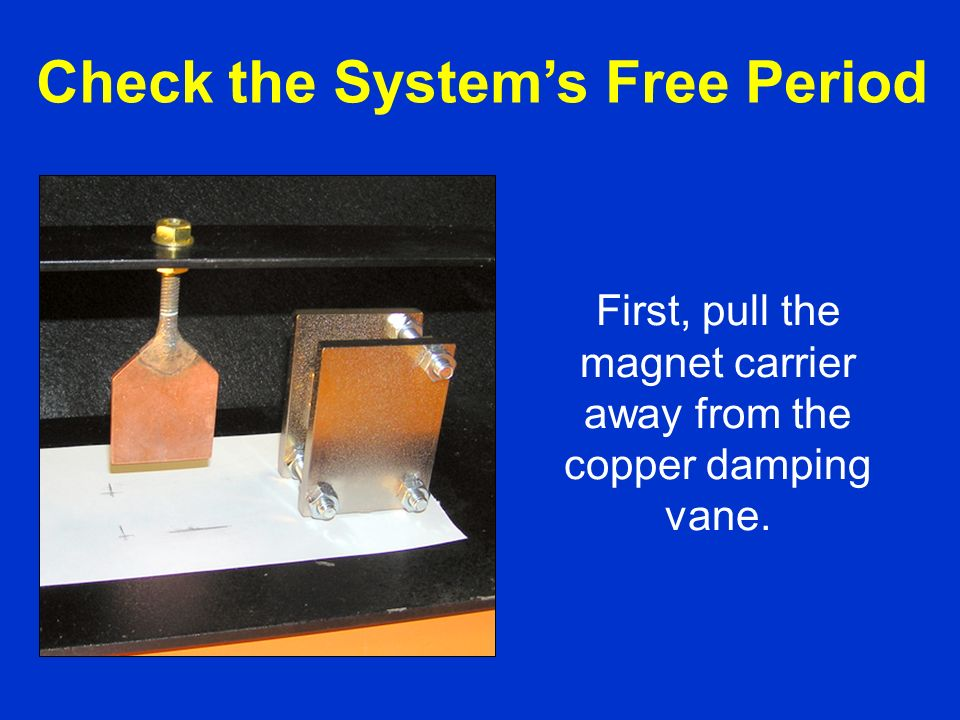How would the damping effect change if the copper vane was cooled to cryogenic temperatures? If the copper vane was cooled to cryogenic temperatures, the damping effect would be significantly enhanced. At very low temperatures, copper's electrical resistance decreases, approaching that of a superconductor. This reduction in resistance allows larger eddy currents to flow more freely when the magnet is moved, resulting in stronger opposing magnetic fields. Consequently, the damping effect would become much more pronounced, with the magnet's motion being more rapidly decelerated. This advanced technique is utilized in applications requiring highly efficient damping, such as in precision instrumentation stabilization and superconducting magnetic bearings used in advanced technology systems. 